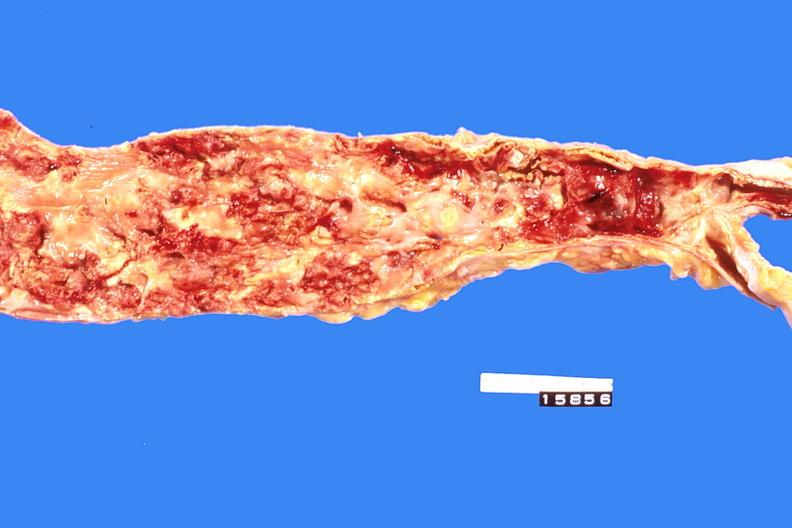where is this?
Answer the question using a single word or phrase. Heart 